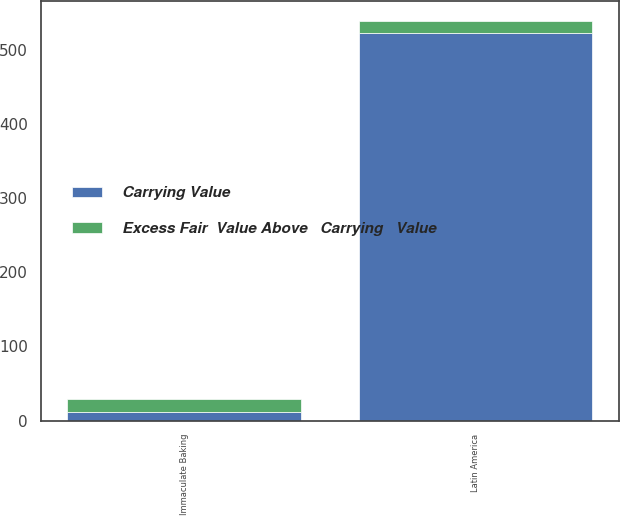Convert chart to OTSL. <chart><loc_0><loc_0><loc_500><loc_500><stacked_bar_chart><ecel><fcel>Latin America<fcel>Immaculate Baking<nl><fcel>Carrying Value<fcel>523<fcel>12<nl><fcel>Excess Fair  Value Above   Carrying   Value<fcel>15<fcel>17<nl></chart> 